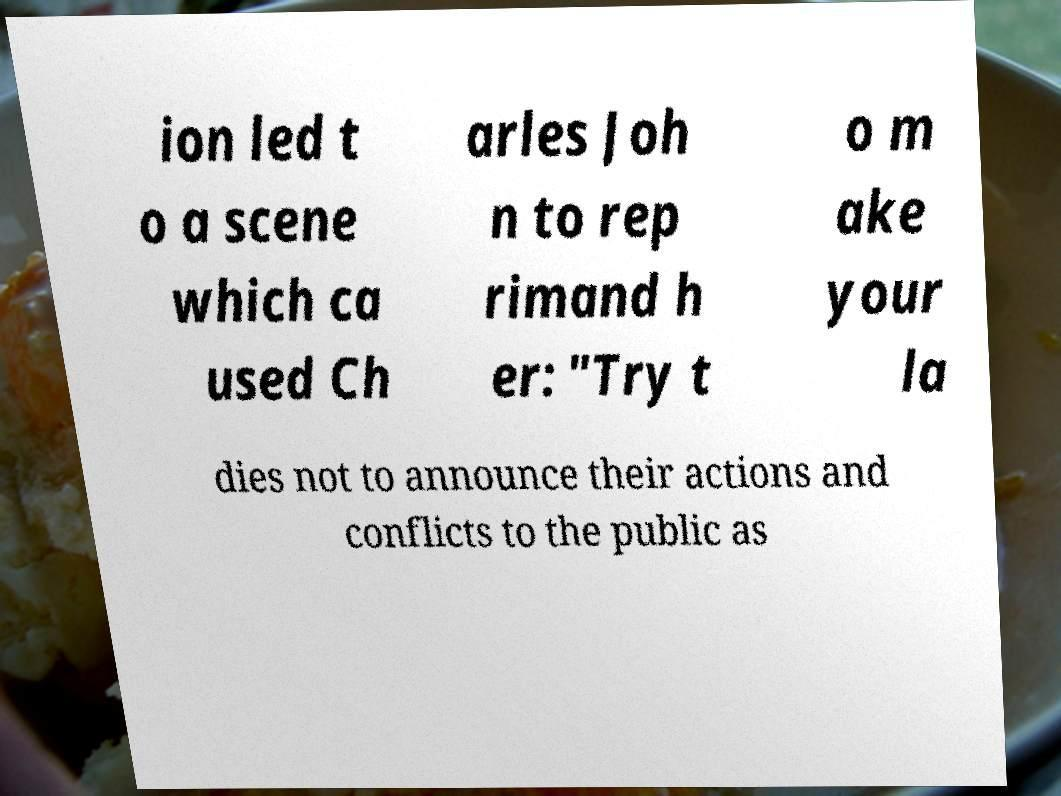Please read and relay the text visible in this image. What does it say? ion led t o a scene which ca used Ch arles Joh n to rep rimand h er: "Try t o m ake your la dies not to announce their actions and conflicts to the public as 